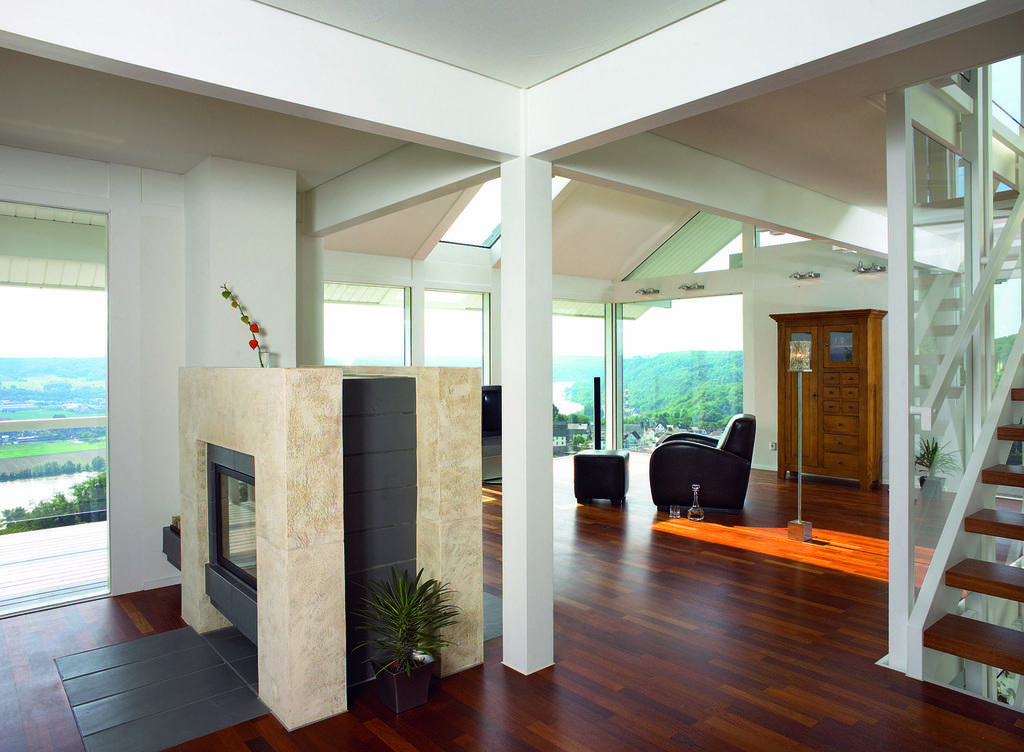What type of location is depicted in the image? The image shows the inside of a building. What type of furniture is present in the image? There is a chair and a table in the image. What is placed on the table? There are potted plants on the table. What type of storage or display units are in the image? There are display cases in the image. Who is the manager of the battle taking place in the image? There is no battle present in the image; it shows the inside of a building with furniture and display cases. 